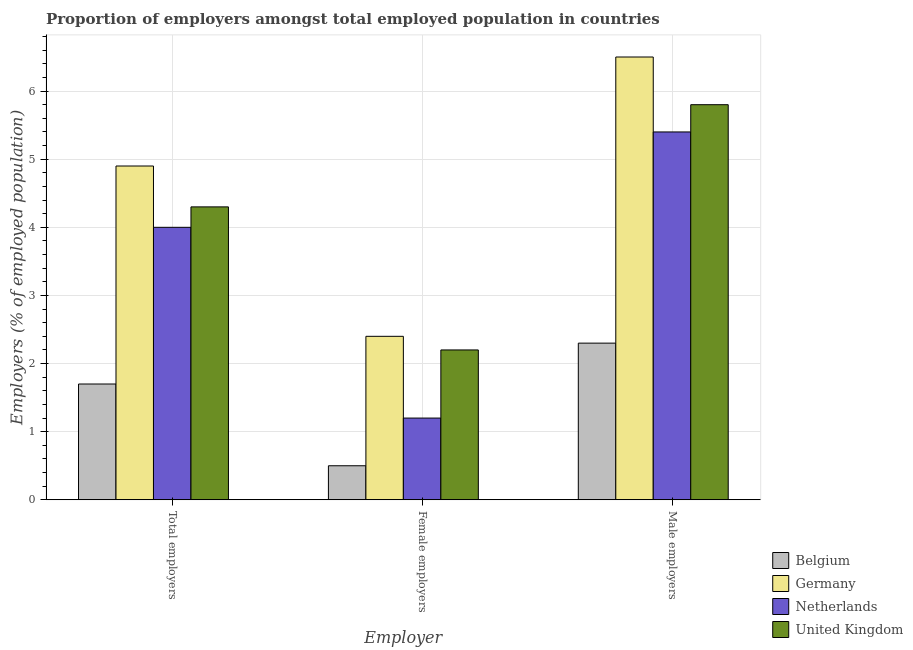How many different coloured bars are there?
Your response must be concise. 4. How many bars are there on the 2nd tick from the right?
Keep it short and to the point. 4. What is the label of the 1st group of bars from the left?
Your answer should be very brief. Total employers. What is the percentage of female employers in Germany?
Your answer should be compact. 2.4. Across all countries, what is the maximum percentage of total employers?
Keep it short and to the point. 4.9. Across all countries, what is the minimum percentage of total employers?
Give a very brief answer. 1.7. In which country was the percentage of total employers minimum?
Offer a terse response. Belgium. What is the total percentage of female employers in the graph?
Your response must be concise. 6.3. What is the difference between the percentage of total employers in Netherlands and that in Germany?
Provide a succinct answer. -0.9. What is the difference between the percentage of female employers in Belgium and the percentage of total employers in United Kingdom?
Offer a very short reply. -3.8. What is the average percentage of female employers per country?
Provide a succinct answer. 1.58. What is the difference between the percentage of female employers and percentage of male employers in Belgium?
Your answer should be very brief. -1.8. What is the ratio of the percentage of female employers in Germany to that in United Kingdom?
Make the answer very short. 1.09. What is the difference between the highest and the second highest percentage of female employers?
Make the answer very short. 0.2. What is the difference between the highest and the lowest percentage of total employers?
Make the answer very short. 3.2. What does the 1st bar from the left in Female employers represents?
Your response must be concise. Belgium. How many bars are there?
Give a very brief answer. 12. What is the difference between two consecutive major ticks on the Y-axis?
Your response must be concise. 1. Does the graph contain grids?
Provide a succinct answer. Yes. How many legend labels are there?
Provide a short and direct response. 4. How are the legend labels stacked?
Make the answer very short. Vertical. What is the title of the graph?
Make the answer very short. Proportion of employers amongst total employed population in countries. What is the label or title of the X-axis?
Make the answer very short. Employer. What is the label or title of the Y-axis?
Keep it short and to the point. Employers (% of employed population). What is the Employers (% of employed population) of Belgium in Total employers?
Make the answer very short. 1.7. What is the Employers (% of employed population) of Germany in Total employers?
Offer a very short reply. 4.9. What is the Employers (% of employed population) of United Kingdom in Total employers?
Your response must be concise. 4.3. What is the Employers (% of employed population) of Belgium in Female employers?
Keep it short and to the point. 0.5. What is the Employers (% of employed population) in Germany in Female employers?
Your answer should be compact. 2.4. What is the Employers (% of employed population) in Netherlands in Female employers?
Your answer should be very brief. 1.2. What is the Employers (% of employed population) of United Kingdom in Female employers?
Ensure brevity in your answer.  2.2. What is the Employers (% of employed population) in Belgium in Male employers?
Your answer should be very brief. 2.3. What is the Employers (% of employed population) of Germany in Male employers?
Provide a short and direct response. 6.5. What is the Employers (% of employed population) of Netherlands in Male employers?
Provide a short and direct response. 5.4. What is the Employers (% of employed population) of United Kingdom in Male employers?
Ensure brevity in your answer.  5.8. Across all Employer, what is the maximum Employers (% of employed population) of Belgium?
Offer a terse response. 2.3. Across all Employer, what is the maximum Employers (% of employed population) in Germany?
Your answer should be compact. 6.5. Across all Employer, what is the maximum Employers (% of employed population) in Netherlands?
Your answer should be compact. 5.4. Across all Employer, what is the maximum Employers (% of employed population) in United Kingdom?
Provide a succinct answer. 5.8. Across all Employer, what is the minimum Employers (% of employed population) in Germany?
Your answer should be compact. 2.4. Across all Employer, what is the minimum Employers (% of employed population) in Netherlands?
Offer a very short reply. 1.2. Across all Employer, what is the minimum Employers (% of employed population) of United Kingdom?
Your response must be concise. 2.2. What is the total Employers (% of employed population) of Belgium in the graph?
Your answer should be very brief. 4.5. What is the total Employers (% of employed population) of Germany in the graph?
Make the answer very short. 13.8. What is the total Employers (% of employed population) in Netherlands in the graph?
Ensure brevity in your answer.  10.6. What is the difference between the Employers (% of employed population) of Germany in Total employers and that in Female employers?
Give a very brief answer. 2.5. What is the difference between the Employers (% of employed population) in Belgium in Total employers and that in Male employers?
Ensure brevity in your answer.  -0.6. What is the difference between the Employers (% of employed population) in Germany in Total employers and that in Male employers?
Offer a terse response. -1.6. What is the difference between the Employers (% of employed population) in Netherlands in Total employers and that in Male employers?
Your response must be concise. -1.4. What is the difference between the Employers (% of employed population) in Belgium in Female employers and that in Male employers?
Ensure brevity in your answer.  -1.8. What is the difference between the Employers (% of employed population) in Netherlands in Female employers and that in Male employers?
Provide a succinct answer. -4.2. What is the difference between the Employers (% of employed population) of Belgium in Total employers and the Employers (% of employed population) of Germany in Female employers?
Your answer should be compact. -0.7. What is the difference between the Employers (% of employed population) of Belgium in Total employers and the Employers (% of employed population) of United Kingdom in Female employers?
Your response must be concise. -0.5. What is the difference between the Employers (% of employed population) in Germany in Total employers and the Employers (% of employed population) in Netherlands in Female employers?
Provide a succinct answer. 3.7. What is the difference between the Employers (% of employed population) in Belgium in Total employers and the Employers (% of employed population) in Netherlands in Male employers?
Provide a succinct answer. -3.7. What is the difference between the Employers (% of employed population) of Germany in Total employers and the Employers (% of employed population) of Netherlands in Male employers?
Give a very brief answer. -0.5. What is the difference between the Employers (% of employed population) in Germany in Total employers and the Employers (% of employed population) in United Kingdom in Male employers?
Keep it short and to the point. -0.9. What is the difference between the Employers (% of employed population) in Netherlands in Total employers and the Employers (% of employed population) in United Kingdom in Male employers?
Your response must be concise. -1.8. What is the difference between the Employers (% of employed population) of Belgium in Female employers and the Employers (% of employed population) of Netherlands in Male employers?
Offer a very short reply. -4.9. What is the difference between the Employers (% of employed population) in Belgium in Female employers and the Employers (% of employed population) in United Kingdom in Male employers?
Your answer should be very brief. -5.3. What is the difference between the Employers (% of employed population) in Germany in Female employers and the Employers (% of employed population) in United Kingdom in Male employers?
Provide a succinct answer. -3.4. What is the difference between the Employers (% of employed population) of Netherlands in Female employers and the Employers (% of employed population) of United Kingdom in Male employers?
Give a very brief answer. -4.6. What is the average Employers (% of employed population) of Netherlands per Employer?
Make the answer very short. 3.53. What is the average Employers (% of employed population) of United Kingdom per Employer?
Provide a short and direct response. 4.1. What is the difference between the Employers (% of employed population) of Belgium and Employers (% of employed population) of Netherlands in Total employers?
Offer a very short reply. -2.3. What is the difference between the Employers (% of employed population) of Belgium and Employers (% of employed population) of United Kingdom in Total employers?
Your answer should be very brief. -2.6. What is the difference between the Employers (% of employed population) of Germany and Employers (% of employed population) of Netherlands in Total employers?
Your response must be concise. 0.9. What is the difference between the Employers (% of employed population) of Germany and Employers (% of employed population) of United Kingdom in Total employers?
Your answer should be compact. 0.6. What is the difference between the Employers (% of employed population) in Belgium and Employers (% of employed population) in Germany in Female employers?
Your answer should be very brief. -1.9. What is the difference between the Employers (% of employed population) in Germany and Employers (% of employed population) in United Kingdom in Female employers?
Your answer should be very brief. 0.2. What is the difference between the Employers (% of employed population) in Netherlands and Employers (% of employed population) in United Kingdom in Female employers?
Ensure brevity in your answer.  -1. What is the difference between the Employers (% of employed population) of Belgium and Employers (% of employed population) of Germany in Male employers?
Your answer should be compact. -4.2. What is the difference between the Employers (% of employed population) of Germany and Employers (% of employed population) of Netherlands in Male employers?
Your response must be concise. 1.1. What is the ratio of the Employers (% of employed population) in Belgium in Total employers to that in Female employers?
Your response must be concise. 3.4. What is the ratio of the Employers (% of employed population) in Germany in Total employers to that in Female employers?
Offer a very short reply. 2.04. What is the ratio of the Employers (% of employed population) in United Kingdom in Total employers to that in Female employers?
Offer a very short reply. 1.95. What is the ratio of the Employers (% of employed population) of Belgium in Total employers to that in Male employers?
Give a very brief answer. 0.74. What is the ratio of the Employers (% of employed population) of Germany in Total employers to that in Male employers?
Offer a very short reply. 0.75. What is the ratio of the Employers (% of employed population) of Netherlands in Total employers to that in Male employers?
Provide a succinct answer. 0.74. What is the ratio of the Employers (% of employed population) in United Kingdom in Total employers to that in Male employers?
Give a very brief answer. 0.74. What is the ratio of the Employers (% of employed population) of Belgium in Female employers to that in Male employers?
Offer a terse response. 0.22. What is the ratio of the Employers (% of employed population) of Germany in Female employers to that in Male employers?
Provide a succinct answer. 0.37. What is the ratio of the Employers (% of employed population) in Netherlands in Female employers to that in Male employers?
Your answer should be very brief. 0.22. What is the ratio of the Employers (% of employed population) in United Kingdom in Female employers to that in Male employers?
Offer a very short reply. 0.38. What is the difference between the highest and the second highest Employers (% of employed population) of Belgium?
Give a very brief answer. 0.6. What is the difference between the highest and the second highest Employers (% of employed population) of Germany?
Your answer should be very brief. 1.6. What is the difference between the highest and the second highest Employers (% of employed population) of Netherlands?
Make the answer very short. 1.4. What is the difference between the highest and the second highest Employers (% of employed population) in United Kingdom?
Make the answer very short. 1.5. What is the difference between the highest and the lowest Employers (% of employed population) of Belgium?
Your answer should be very brief. 1.8. What is the difference between the highest and the lowest Employers (% of employed population) in Germany?
Your answer should be compact. 4.1. 